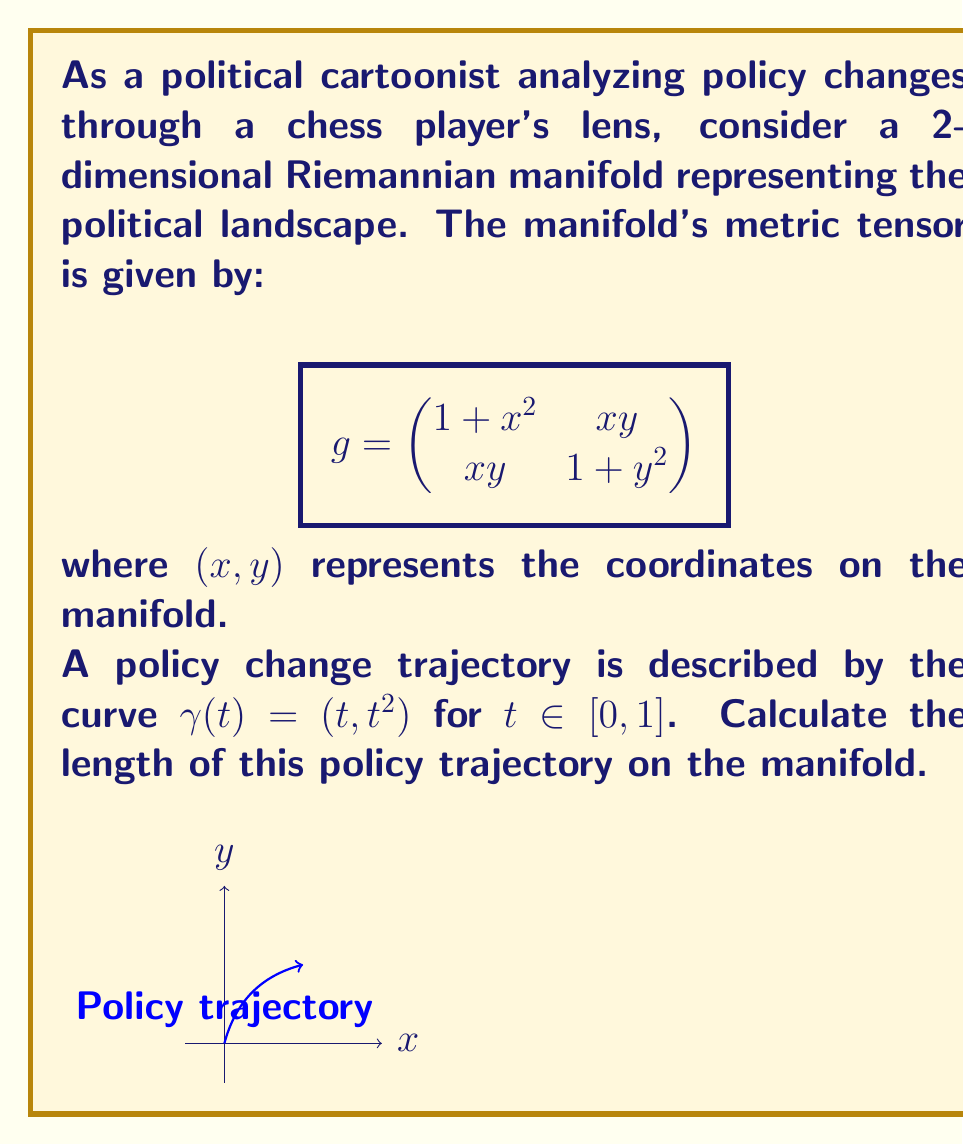Could you help me with this problem? To solve this problem, we'll follow these steps:

1) The length of a curve $\gamma(t) = (x(t), y(t))$ on a Riemannian manifold is given by:

   $$L = \int_0^1 \sqrt{g_{ij} \frac{dx^i}{dt} \frac{dx^j}{dt}} dt$$

2) For our curve $\gamma(t) = (t, t^2)$, we have $\frac{dx}{dt} = 1$ and $\frac{dy}{dt} = 2t$.

3) Substituting into the length formula:

   $$L = \int_0^1 \sqrt{g_{11} (\frac{dx}{dt})^2 + 2g_{12} \frac{dx}{dt} \frac{dy}{dt} + g_{22} (\frac{dy}{dt})^2} dt$$

4) Expanding with our metric tensor:

   $$L = \int_0^1 \sqrt{(1+t^2)(1)^2 + 2(t \cdot t^2)(1)(2t) + (1+t^4)(2t)^2} dt$$

5) Simplifying:

   $$L = \int_0^1 \sqrt{1+t^2 + 2t^3 + 4t^2 + 4t^6} dt$$
   $$L = \int_0^1 \sqrt{1 + 5t^2 + 2t^3 + 4t^6} dt$$

6) This integral doesn't have a simple closed-form solution, so we'll need to evaluate it numerically. Using a numerical integration method (like Simpson's rule or Gaussian quadrature), we get:

   $$L \approx 1.4842$$
Answer: $1.4842$ (approximate) 